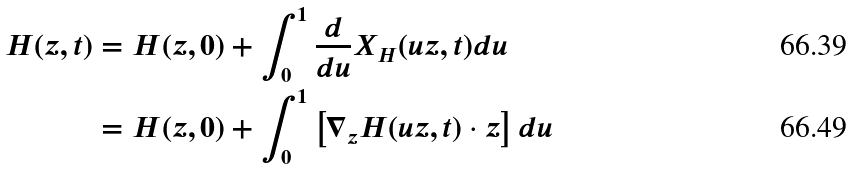Convert formula to latex. <formula><loc_0><loc_0><loc_500><loc_500>H ( z , t ) & = H ( z , 0 ) + \int _ { 0 } ^ { 1 } \frac { d } { d u } X _ { H } ( u z , t ) d u \\ & = H ( z , 0 ) + \int _ { 0 } ^ { 1 } \left [ \nabla _ { z } H ( u z , t ) \cdot z \right ] d u</formula> 